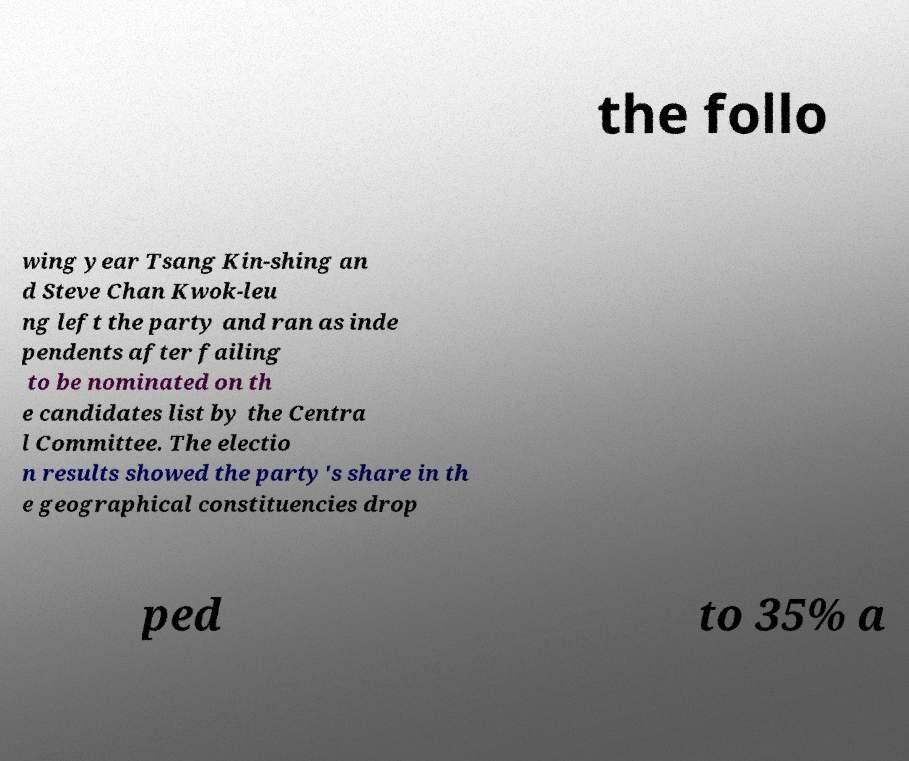Please identify and transcribe the text found in this image. the follo wing year Tsang Kin-shing an d Steve Chan Kwok-leu ng left the party and ran as inde pendents after failing to be nominated on th e candidates list by the Centra l Committee. The electio n results showed the party's share in th e geographical constituencies drop ped to 35% a 